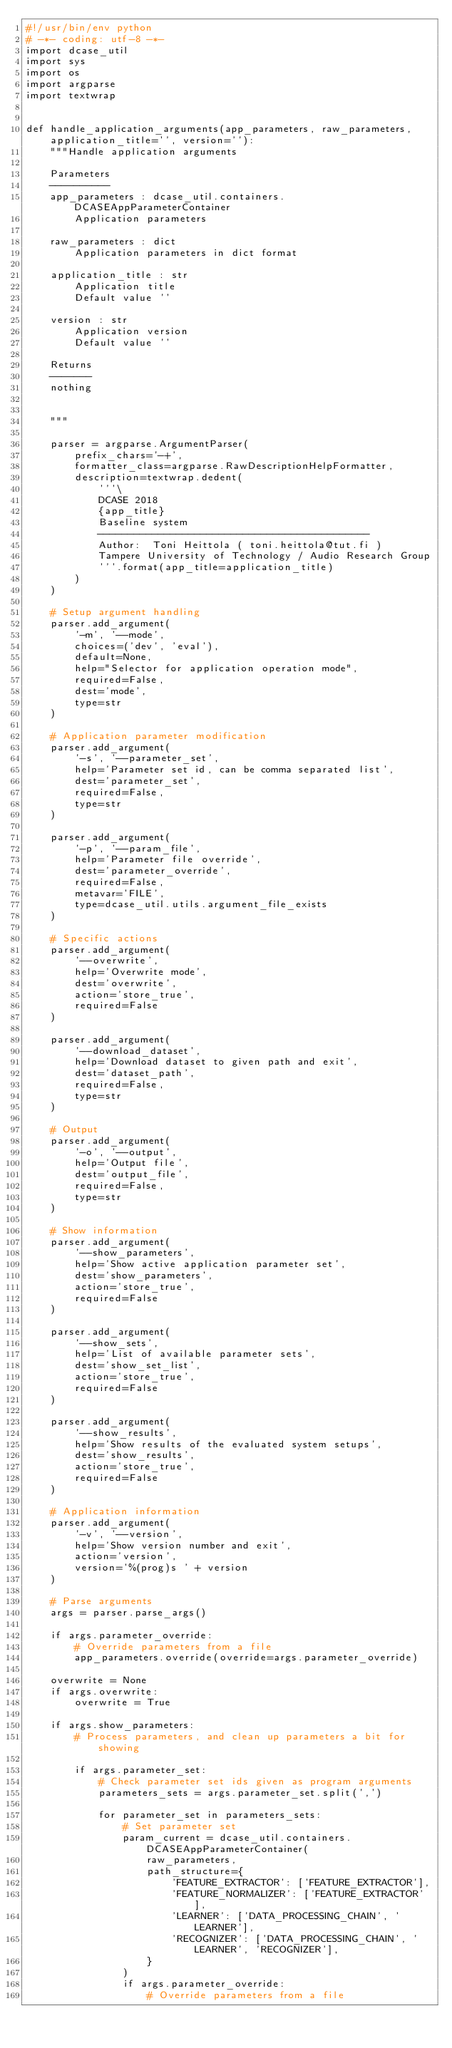<code> <loc_0><loc_0><loc_500><loc_500><_Python_>#!/usr/bin/env python
# -*- coding: utf-8 -*-
import dcase_util
import sys
import os
import argparse
import textwrap


def handle_application_arguments(app_parameters, raw_parameters, application_title='', version=''):
    """Handle application arguments

    Parameters
    ----------
    app_parameters : dcase_util.containers.DCASEAppParameterContainer
        Application parameters

    raw_parameters : dict
        Application parameters in dict format

    application_title : str
        Application title
        Default value ''

    version : str
        Application version
        Default value ''

    Returns
    -------
    nothing


    """

    parser = argparse.ArgumentParser(
        prefix_chars='-+',
        formatter_class=argparse.RawDescriptionHelpFormatter,
        description=textwrap.dedent(
            '''\
            DCASE 2018 
            {app_title}
            Baseline system
            ---------------------------------------------            
            Author:  Toni Heittola ( toni.heittola@tut.fi )
            Tampere University of Technology / Audio Research Group
            '''.format(app_title=application_title)
        )
    )

    # Setup argument handling
    parser.add_argument(
        '-m', '--mode',
        choices=('dev', 'eval'),
        default=None,
        help="Selector for application operation mode",
        required=False,
        dest='mode',
        type=str
    )

    # Application parameter modification
    parser.add_argument(
        '-s', '--parameter_set',
        help='Parameter set id, can be comma separated list',
        dest='parameter_set',
        required=False,
        type=str
    )

    parser.add_argument(
        '-p', '--param_file',
        help='Parameter file override',
        dest='parameter_override',
        required=False,
        metavar='FILE',
        type=dcase_util.utils.argument_file_exists
    )

    # Specific actions
    parser.add_argument(
        '--overwrite',
        help='Overwrite mode',
        dest='overwrite',
        action='store_true',
        required=False
    )

    parser.add_argument(
        '--download_dataset',
        help='Download dataset to given path and exit',
        dest='dataset_path',
        required=False,
        type=str
    )

    # Output
    parser.add_argument(
        '-o', '--output',
        help='Output file',
        dest='output_file',
        required=False,
        type=str
    )

    # Show information
    parser.add_argument(
        '--show_parameters',
        help='Show active application parameter set',
        dest='show_parameters',
        action='store_true',
        required=False
    )

    parser.add_argument(
        '--show_sets',
        help='List of available parameter sets',
        dest='show_set_list',
        action='store_true',
        required=False
    )

    parser.add_argument(
        '--show_results',
        help='Show results of the evaluated system setups',
        dest='show_results',
        action='store_true',
        required=False
    )

    # Application information
    parser.add_argument(
        '-v', '--version',
        help='Show version number and exit',
        action='version',
        version='%(prog)s ' + version
    )

    # Parse arguments
    args = parser.parse_args()

    if args.parameter_override:
        # Override parameters from a file
        app_parameters.override(override=args.parameter_override)

    overwrite = None
    if args.overwrite:
        overwrite = True

    if args.show_parameters:
        # Process parameters, and clean up parameters a bit for showing

        if args.parameter_set:
            # Check parameter set ids given as program arguments
            parameters_sets = args.parameter_set.split(',')

            for parameter_set in parameters_sets:
                # Set parameter set
                param_current = dcase_util.containers.DCASEAppParameterContainer(
                    raw_parameters,
                    path_structure={
                        'FEATURE_EXTRACTOR': ['FEATURE_EXTRACTOR'],
                        'FEATURE_NORMALIZER': ['FEATURE_EXTRACTOR'],
                        'LEARNER': ['DATA_PROCESSING_CHAIN', 'LEARNER'],
                        'RECOGNIZER': ['DATA_PROCESSING_CHAIN', 'LEARNER', 'RECOGNIZER'],
                    }
                )
                if args.parameter_override:
                    # Override parameters from a file</code> 